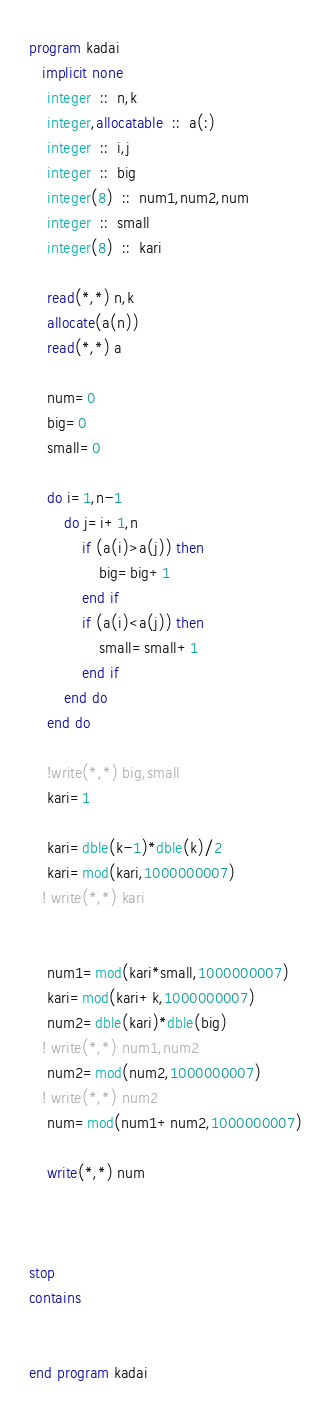Convert code to text. <code><loc_0><loc_0><loc_500><loc_500><_FORTRAN_>program kadai
   implicit none
    integer  ::  n,k
    integer,allocatable  ::  a(:)
    integer  ::  i,j
    integer  ::  big
    integer(8)  ::  num1,num2,num
    integer  ::  small
    integer(8)  ::  kari

    read(*,*) n,k
    allocate(a(n))
    read(*,*) a

    num=0
    big=0
    small=0

    do i=1,n-1
        do j=i+1,n
            if (a(i)>a(j)) then
                big=big+1
            end if
            if (a(i)<a(j)) then
                small=small+1
            end if
        end do
    end do

    !write(*,*) big,small
    kari=1

    kari=dble(k-1)*dble(k)/2
    kari=mod(kari,1000000007)
   ! write(*,*) kari


    num1=mod(kari*small,1000000007)
    kari=mod(kari+k,1000000007)
    num2=dble(kari)*dble(big)
   ! write(*,*) num1,num2
    num2=mod(num2,1000000007)
   ! write(*,*) num2
    num=mod(num1+num2,1000000007)

    write(*,*) num



stop
contains


end program kadai</code> 